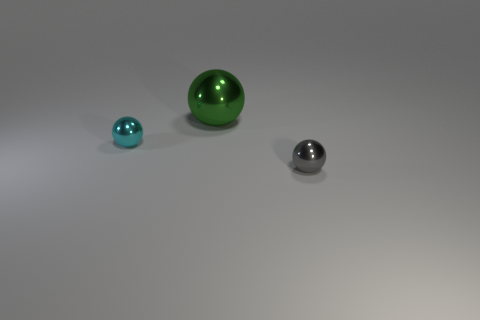Add 3 tiny cyan spheres. How many objects exist? 6 Add 3 cyan spheres. How many cyan spheres are left? 4 Add 1 green balls. How many green balls exist? 2 Subtract 0 yellow spheres. How many objects are left? 3 Subtract all big gray matte cubes. Subtract all tiny metallic balls. How many objects are left? 1 